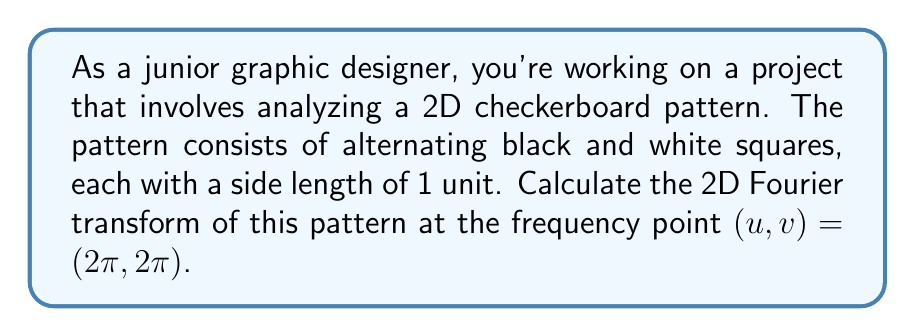Teach me how to tackle this problem. Let's approach this step-by-step:

1) First, we need to represent our 2D checkerboard pattern mathematically. We can describe it using the function:

   $$f(x,y) = \frac{1}{2}[1 + \text{sgn}(\sin(\pi x)\sin(\pi y))]$$

   Where sgn is the sign function.

2) The 2D Fourier transform is given by:

   $$F(u,v) = \int_{-\infty}^{\infty}\int_{-\infty}^{\infty} f(x,y)e^{-i(ux+vy)}dxdy$$

3) Substituting our function and the given frequency point:

   $$F(2\pi,2\pi) = \int_{-\infty}^{\infty}\int_{-\infty}^{\infty} \frac{1}{2}[1 + \text{sgn}(\sin(\pi x)\sin(\pi y))]e^{-i2\pi(x+y)}dxdy$$

4) Due to the periodicity of the pattern, we can simplify our integral to cover just one period:

   $$F(2\pi,2\pi) = 4\int_{0}^{1}\int_{0}^{1} \frac{1}{2}[1 + \text{sgn}(\sin(\pi x)\sin(\pi y))]e^{-i2\pi(x+y)}dxdy$$

5) The sgn term alternates between +1 and -1 in each quadrant of the unit square. This results in:

   $$F(2\pi,2\pi) = 4\int_{0}^{1}\int_{0}^{1} e^{-i2\pi(x+y)}dxdy - 4\int_{0}^{0.5}\int_{0}^{0.5} e^{-i2\pi(x+y)}dxdy - 4\int_{0.5}^{1}\int_{0.5}^{1} e^{-i2\pi(x+y)}dxdy$$

6) Evaluating these integrals:

   $$F(2\pi,2\pi) = 4 \cdot 1 - 4 \cdot \frac{1}{4} - 4 \cdot \frac{1}{4} = 2$$

Therefore, the 2D Fourier transform of the checkerboard pattern at $(u,v) = (2\pi,2\pi)$ is 2.
Answer: 2 